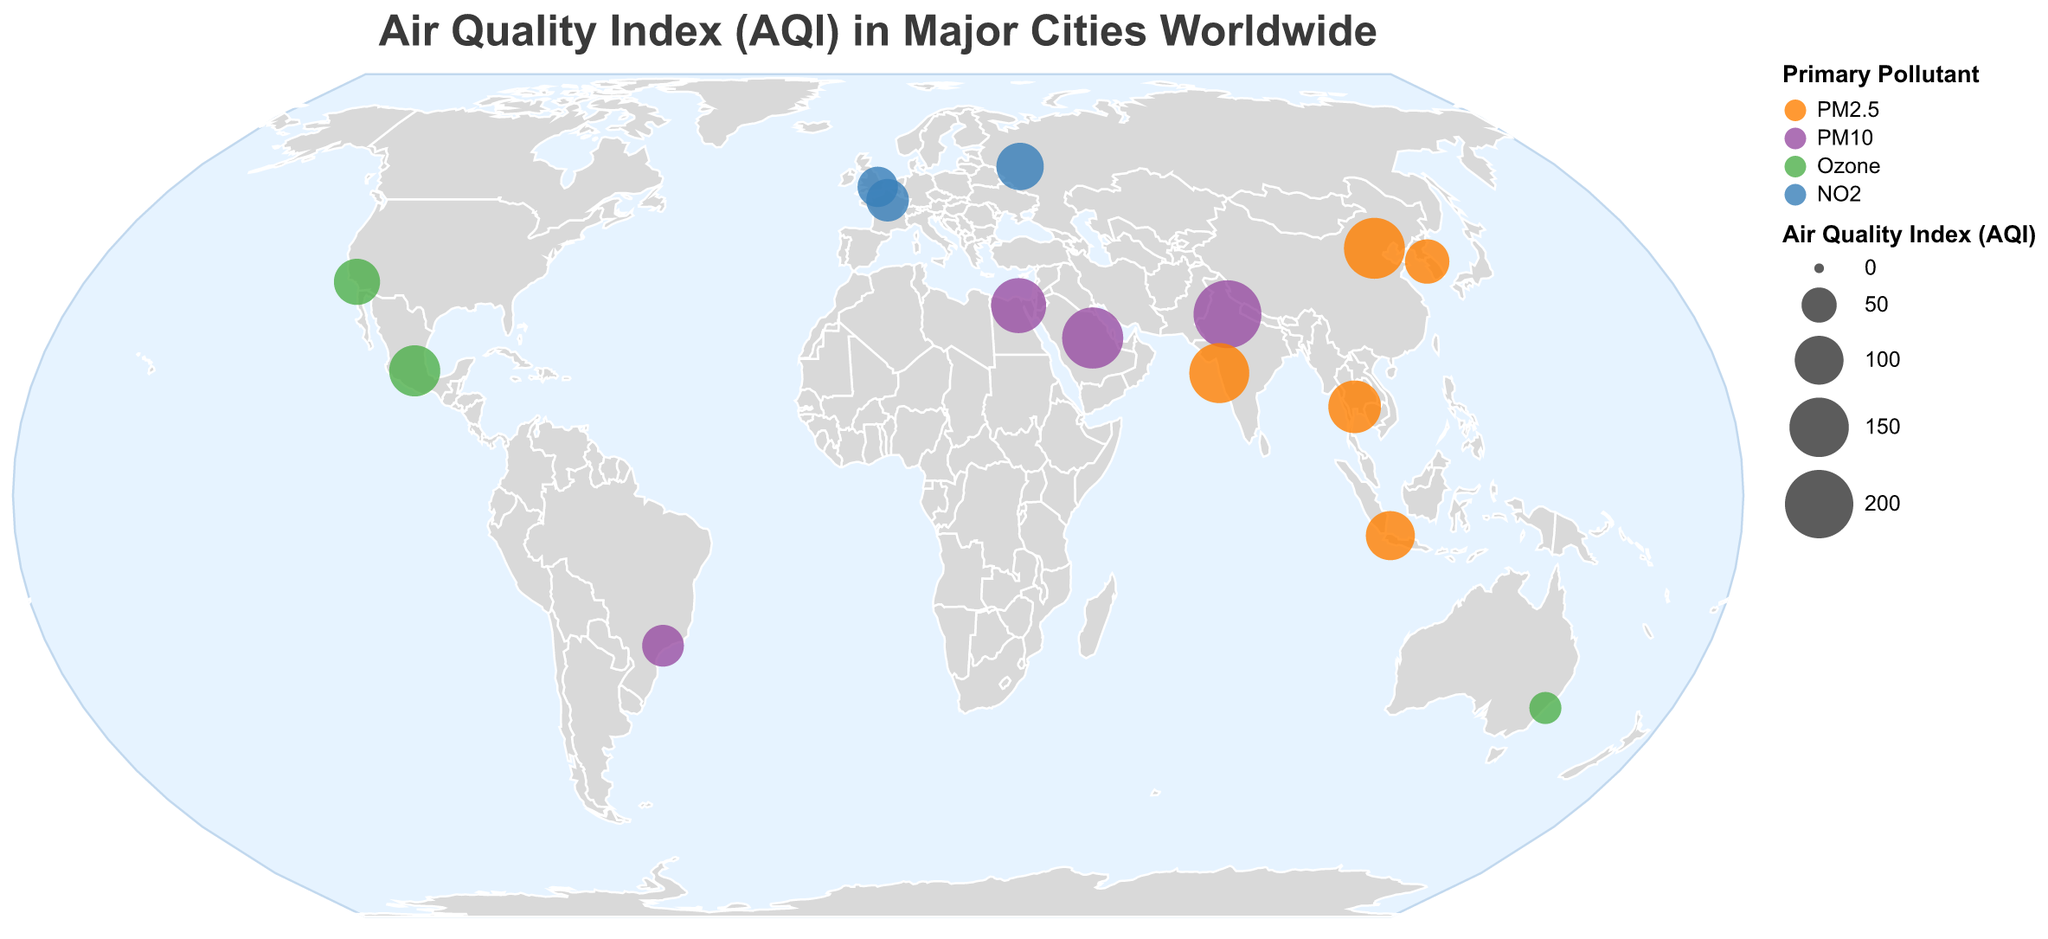What is the primary pollutant in Beijing? The figure shows markers for different cities with the primary pollutant color-coded. For Beijing, the primary pollutant is shown in the legend.
Answer: PM2.5 Which city has the highest AQI value, and what is its primary pollutant? By observing the sizes of the circles, New Delhi has the largest circle, indicating the highest AQI. The color of this circle corresponds to PM10 in the legend.
Answer: New Delhi, PM10 How many cities have Ozone as their primary pollutant? Identifying the color assigned to 'Ozone' in the legend and counting its occurrences on the map, we see Los Angeles, Mexico City, and Sydney.
Answer: 3 Compare the AQI of Cairo and Jakarta. Which is higher and by how much? Cairo shows an AQI of 128 and Jakarta 101. Subtracting Jakarta's AQI from Cairo's gives the difference.
Answer: Cairo, 27 What is the average AQI of Beijing, Mumbai, and Riyadh? Summing the AQI values for Beijing (158), Mumbai (153), and Riyadh (159), and then dividing by 3.
Answer: 156.67 Which city has the lowest AQI, and what is its primary pollutant? The smallest circle on the map represents Sydney. Referring to the legend, Ozone is its primary pollutant.
Answer: Sydney, Ozone How does London’s AQI compare to that of Paris? The AQI for London is 67 and for Paris is 75. Comparing these values, Paris has a higher AQI.
Answer: Paris, by 8 Which city in the USA is included, and what is its AQI and primary pollutant? Referring to the city names and matching the latitude and longitude coordinates, Los Angeles is in the USA, with an AQI of 89 and Ozone as its primary pollutant.
Answer: Los Angeles, 89, Ozone What is the total number of cities shown on the map? Counting each of the data points representing different cities gives the total number.
Answer: 15 What does the color blue represent in the plot? By checking the legend, blue is associated with NO2.
Answer: NO2 